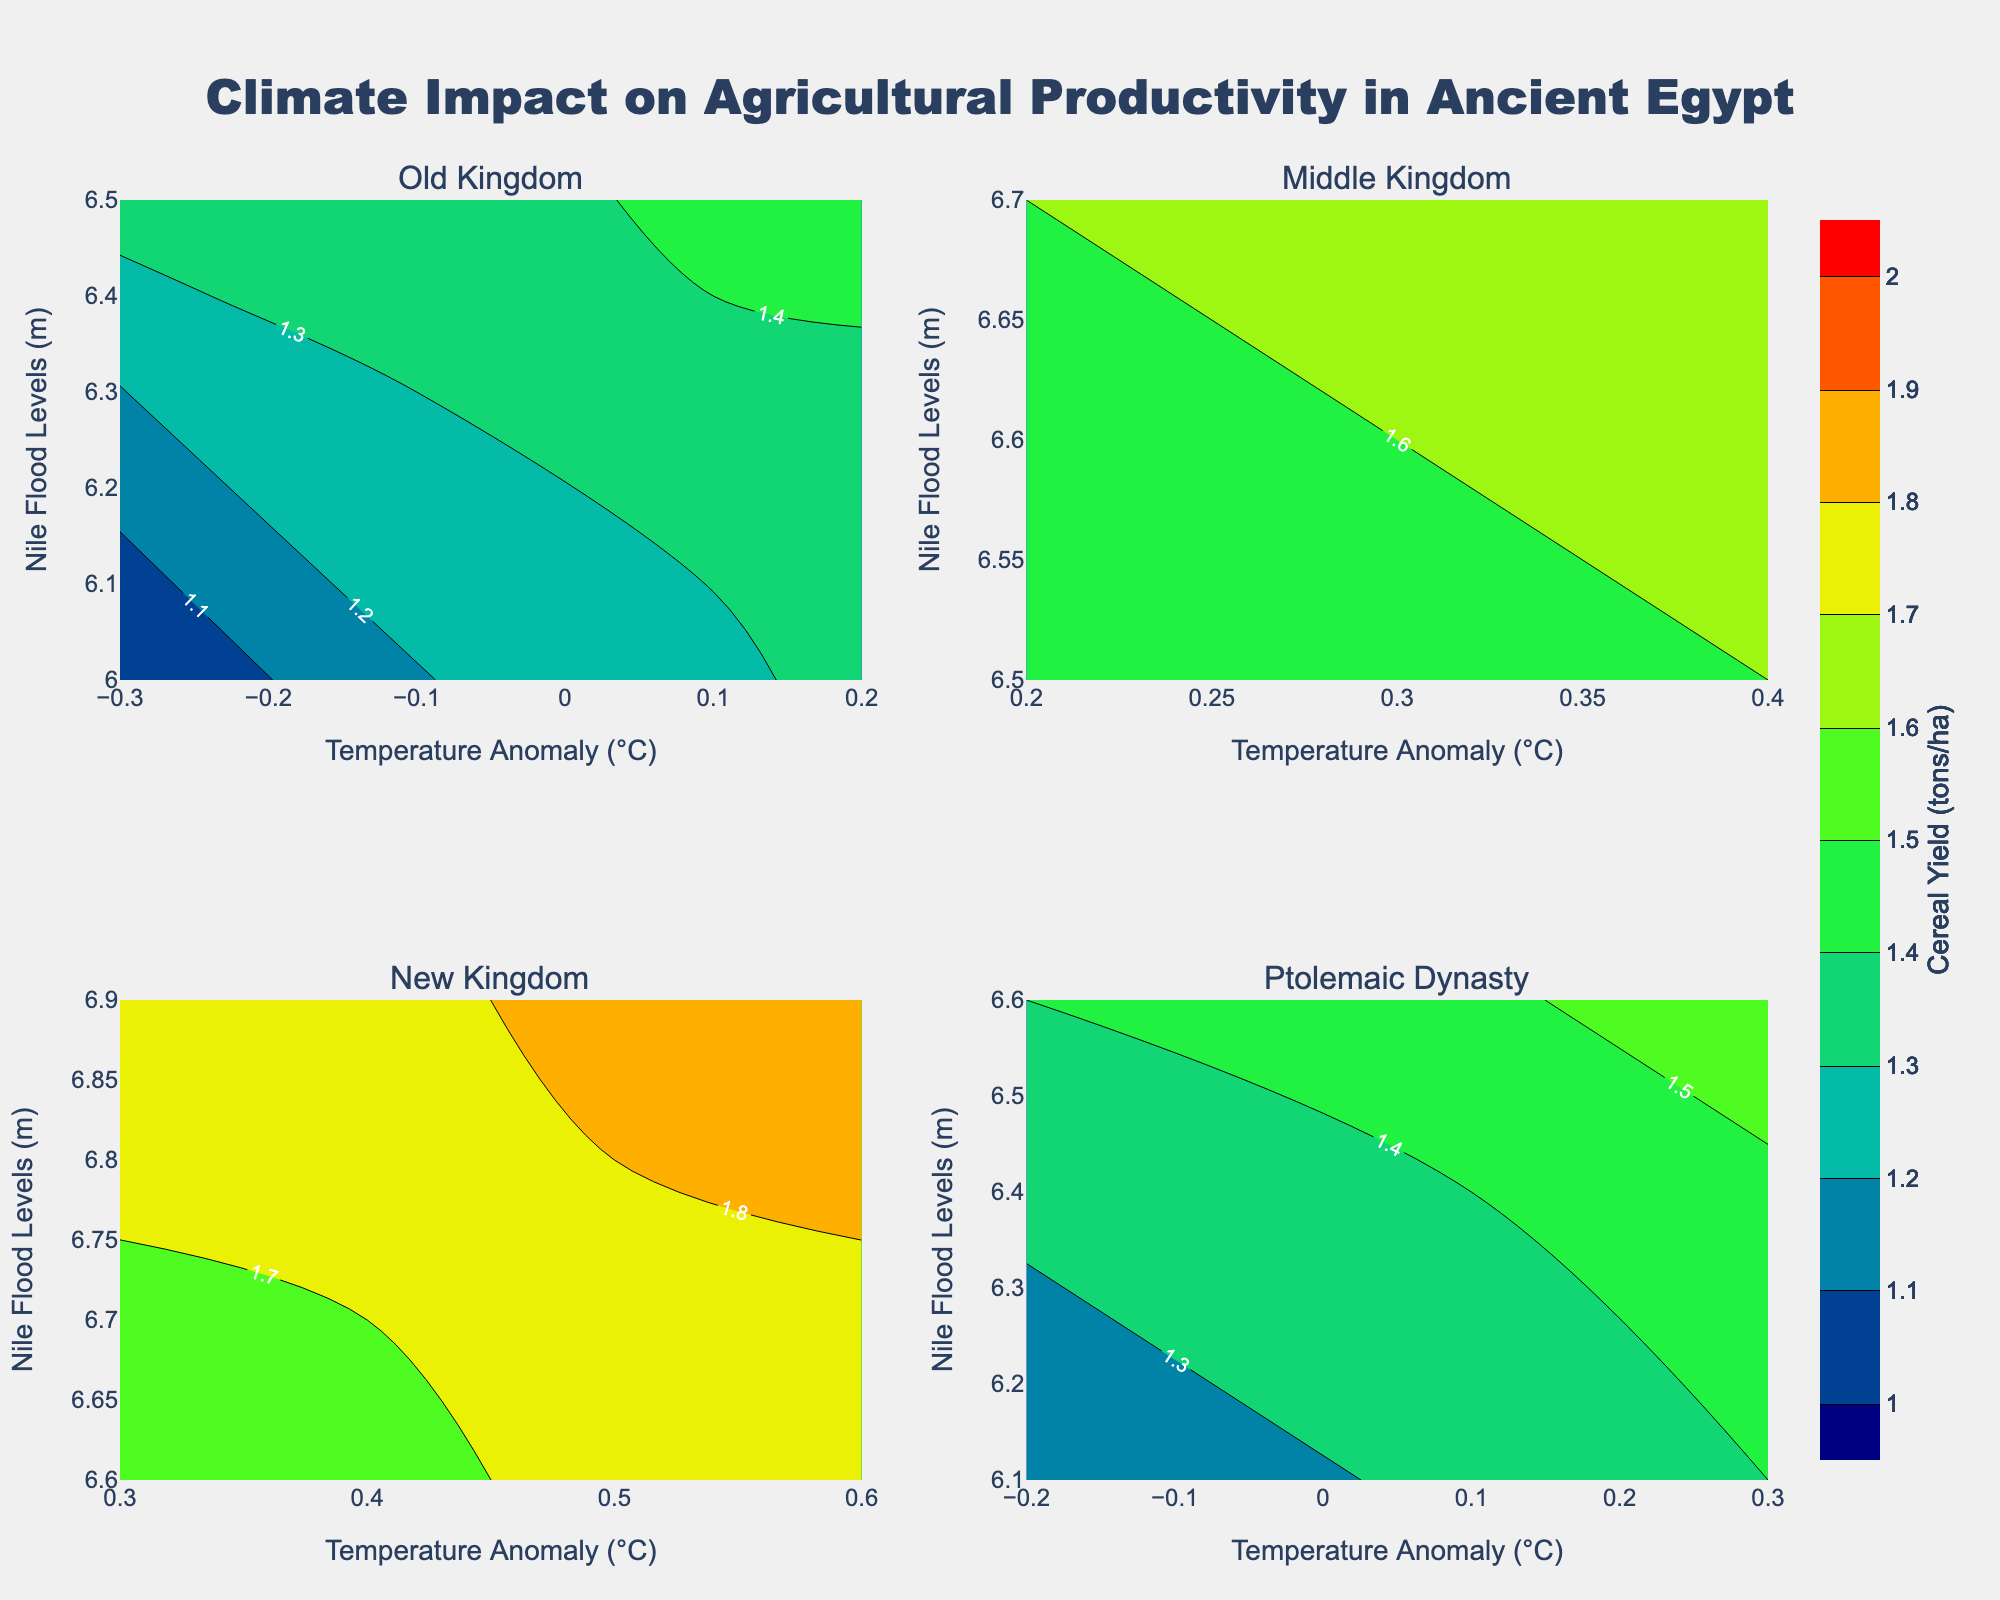How many subplots are displayed in the figure? There are four dynasties represented in the dataset (Old Kingdom, Middle Kingdom, New Kingdom, and Ptolemaic Dynasty) and each dynasty has its own subplot, making a total of four subplots.
Answer: Four What is the color used to indicate the highest cereal yield on the contour plots? The highest cereal yield on the contour plots is shown using a red color as per the color scale provided.
Answer: Red Which dynasty shows the highest recorded cereal yield (tons/ha)? On examining the contour plots, the New Kingdom subplot displays the highest cereal yield marked at 1.9 tons/ha when the temperature anomaly is 0.6°C and Nile flood levels are 6.9m.
Answer: New Kingdom What is the trend of cereal yield in the Old Kingdom as temperature anomaly decreases? In the Old Kingdom subplot, as the temperature anomaly decreases, the cereal yield also decreases, following a downward trend.
Answer: Decreases Which subplot appears to have the most stable cereal yield in relation to temperature anomaly? The Middle Kingdom subplot shows the least fluctuation in cereal yield with changing temperature anomaly, suggesting a more stable agricultural productivity.
Answer: Middle Kingdom How does the cereal yield in the Ptolemaic Dynasty at a temperature anomaly of 0.3°C compare to the yield at 0.1°C? In the Ptolemaic Dynasty subplot, at a temperature anomaly of 0.3°C, the cereal yield is 1.6 tons/ha, whereas at 0.1°C, it is 1.4 tons/ha, indicating an increase in yield with a rise in temperature anomaly.
Answer: Yield increases Which dynasty shows a correlation where higher Nile flood levels result in higher cereal yield? In the New Kingdom subplot, higher Nile flood levels correlate with higher cereal yields, observable as the contour shifts upward along both the y-axis and yield values.
Answer: New Kingdom What can be inferred about the agricultural productivity in the Middle Kingdom from the contour lines for cereal yield? The contour lines in the Middle Kingdom subplot indicate that cereal yield (1.6-1.7 tons/ha) remains relatively stable across different levels of temperature anomalies and Nile flood levels. This suggests consistent agricultural productivity.
Answer: Stable productivity 